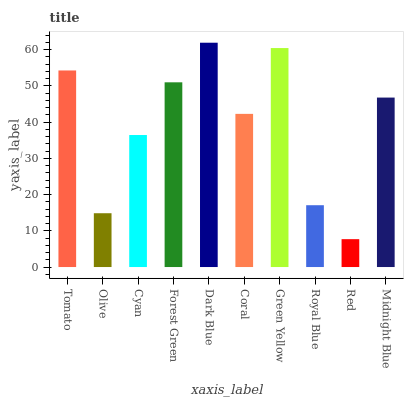Is Red the minimum?
Answer yes or no. Yes. Is Dark Blue the maximum?
Answer yes or no. Yes. Is Olive the minimum?
Answer yes or no. No. Is Olive the maximum?
Answer yes or no. No. Is Tomato greater than Olive?
Answer yes or no. Yes. Is Olive less than Tomato?
Answer yes or no. Yes. Is Olive greater than Tomato?
Answer yes or no. No. Is Tomato less than Olive?
Answer yes or no. No. Is Midnight Blue the high median?
Answer yes or no. Yes. Is Coral the low median?
Answer yes or no. Yes. Is Forest Green the high median?
Answer yes or no. No. Is Cyan the low median?
Answer yes or no. No. 